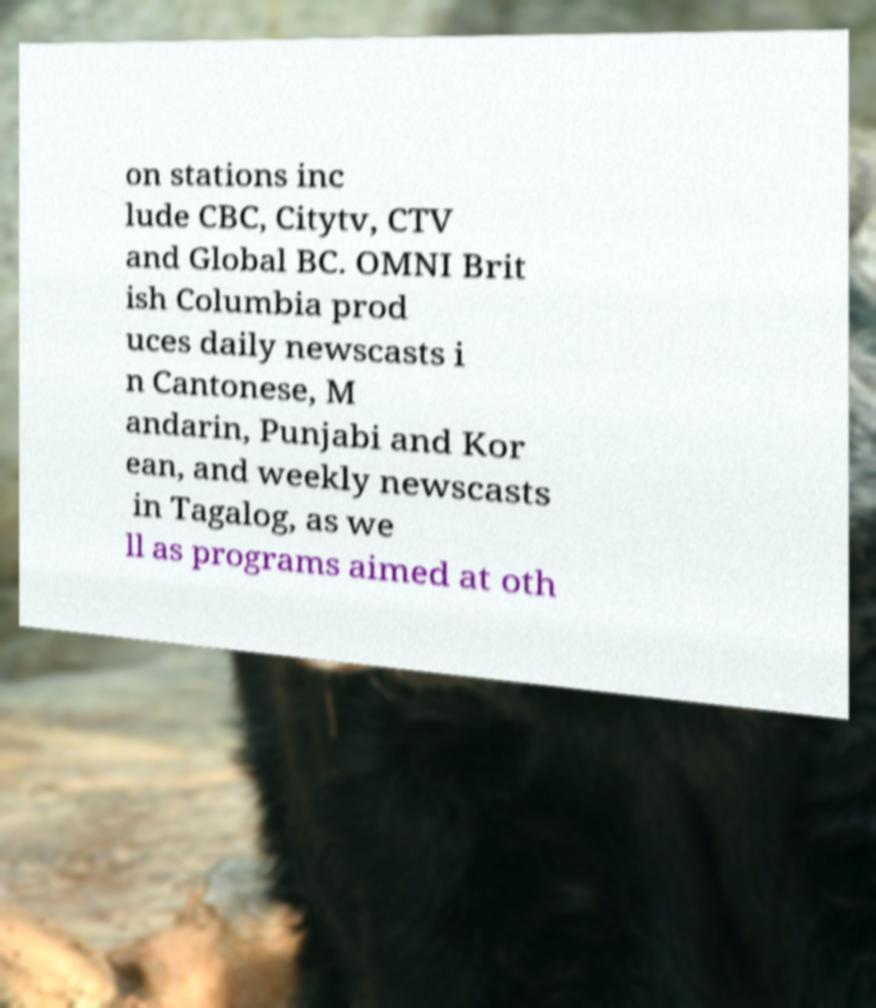For documentation purposes, I need the text within this image transcribed. Could you provide that? on stations inc lude CBC, Citytv, CTV and Global BC. OMNI Brit ish Columbia prod uces daily newscasts i n Cantonese, M andarin, Punjabi and Kor ean, and weekly newscasts in Tagalog, as we ll as programs aimed at oth 